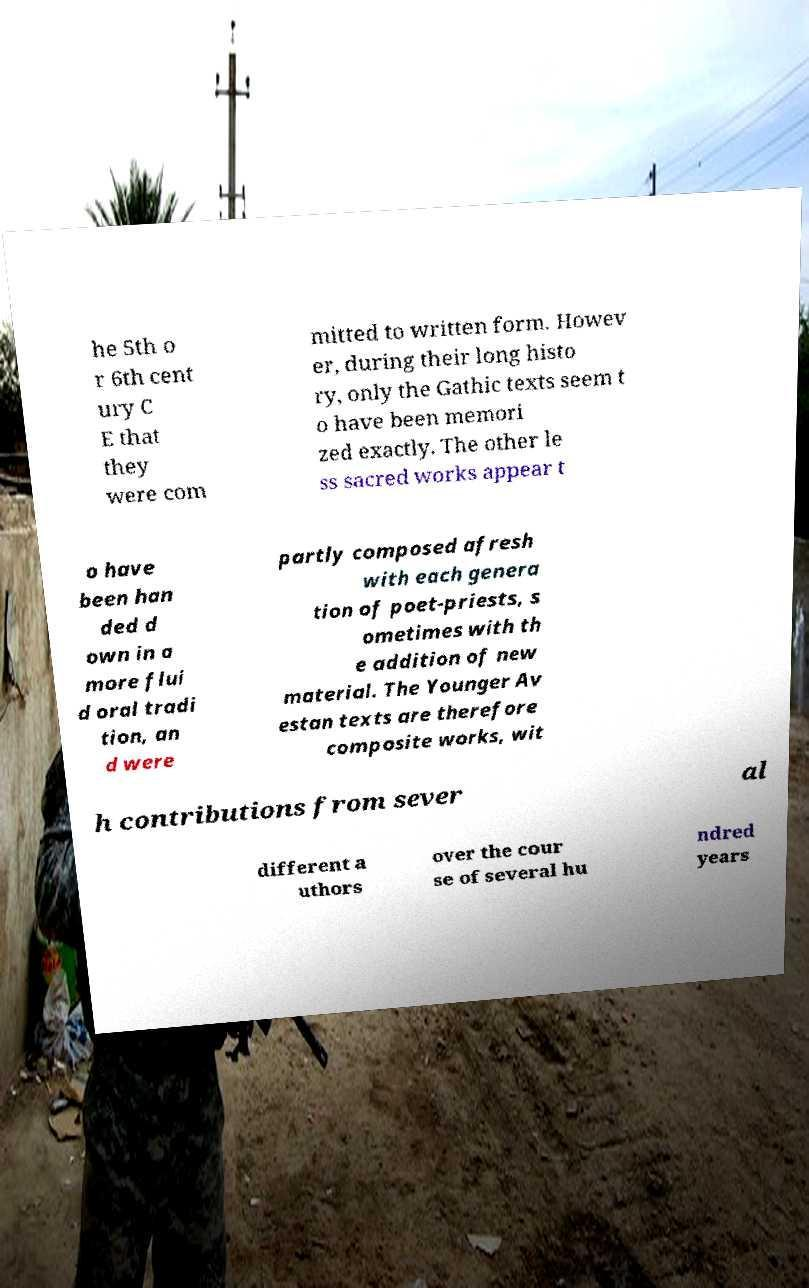For documentation purposes, I need the text within this image transcribed. Could you provide that? he 5th o r 6th cent ury C E that they were com mitted to written form. Howev er, during their long histo ry, only the Gathic texts seem t o have been memori zed exactly. The other le ss sacred works appear t o have been han ded d own in a more flui d oral tradi tion, an d were partly composed afresh with each genera tion of poet-priests, s ometimes with th e addition of new material. The Younger Av estan texts are therefore composite works, wit h contributions from sever al different a uthors over the cour se of several hu ndred years 